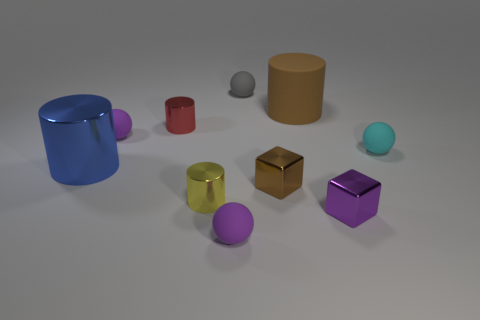Are any big gray matte objects visible?
Your response must be concise. No. What color is the other big object that is the same shape as the blue shiny object?
Your response must be concise. Brown. There is another cylinder that is the same size as the blue shiny cylinder; what is its color?
Provide a succinct answer. Brown. Is the tiny yellow object made of the same material as the big brown object?
Offer a very short reply. No. What number of other things are the same color as the big rubber thing?
Your answer should be compact. 1. What material is the large cylinder that is left of the brown shiny cube?
Provide a succinct answer. Metal. What number of small objects are either matte objects or brown cubes?
Provide a succinct answer. 5. Is there a gray sphere made of the same material as the tiny yellow cylinder?
Give a very brief answer. No. Do the rubber ball that is left of the yellow shiny cylinder and the big blue shiny cylinder have the same size?
Your response must be concise. No. There is a brown object in front of the sphere that is right of the tiny gray matte ball; are there any spheres that are behind it?
Your answer should be compact. Yes. 